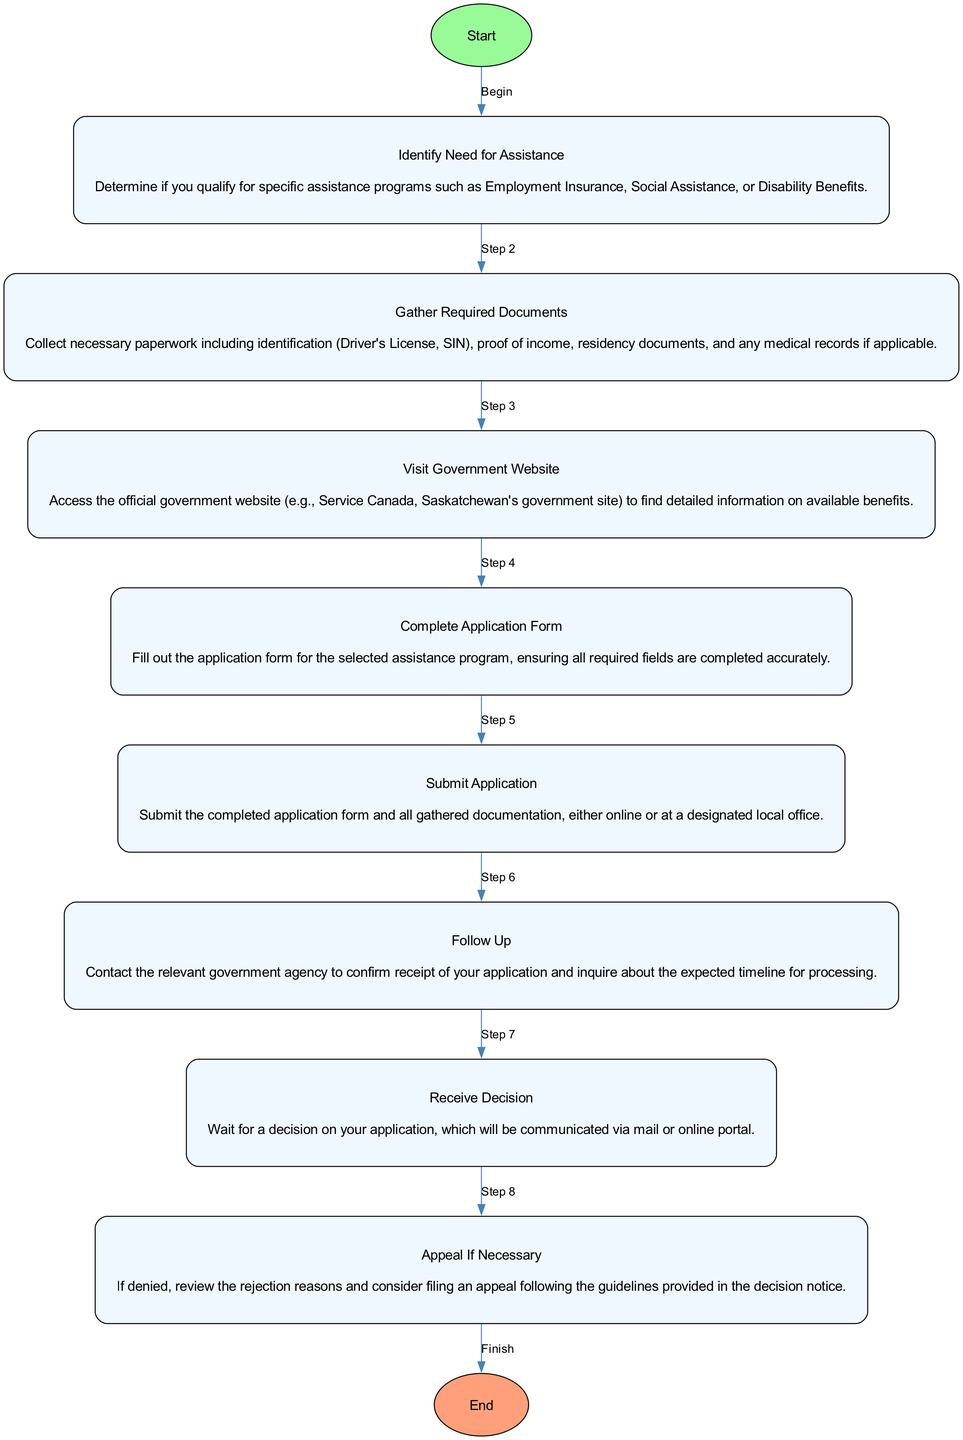What is the first step in the process? The first step in the diagram is labeled as "Identify Need for Assistance." This node is the one that starts the flow and initiates the entire process of applying for government benefits.
Answer: Identify Need for Assistance How many steps are in the diagram? By counting the nodes between the "Start" and "End" nodes, there are a total of 8 steps in the process outlined in the diagram.
Answer: 8 What is required before submitting the application? According to the flow, the required action before the application submission is to "Gather Required Documents," where necessary paperwork is collected.
Answer: Gather Required Documents What document is necessary for identification? Among the listed required documents, a "Driver's License" is explicitly mentioned as one of the forms of identification needed.
Answer: Driver's License What follows after submitting the application? After submitting the application, the next step in the diagram, denoted by an arrow leading from the submission, is "Follow Up." This means you need to contact the agency for confirmation.
Answer: Follow Up What happens if the application is denied? If an application is denied, the diagram indicates that the next step is to "Appeal If Necessary," which involves reviewing the rejection reasons and considering filing an appeal.
Answer: Appeal If Necessary Which step requires visiting a government website? The "Visit Government Website" step is clearly marked as the third step in the process listed in the diagram, where individuals access official information about benefits.
Answer: Visit Government Website What indicates the end of the process? The end of the process is marked by the "End" node, which does not involve any further actions or steps but signifies that all necessary steps have been completed.
Answer: End Which node does the "Complete Application Form" connect to? "Complete Application Form" is connected to "Gather Required Documents," as it is the next step that follows after gathering the required documents has been completed.
Answer: Gather Required Documents 